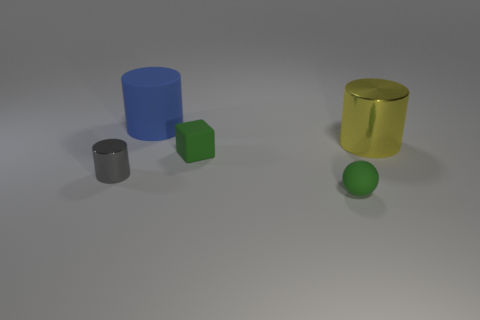There is a large cylinder in front of the big thing on the left side of the large yellow cylinder; what is it made of?
Give a very brief answer. Metal. There is a gray object that is the same shape as the big blue rubber object; what is it made of?
Offer a very short reply. Metal. Does the metallic thing right of the cube have the same size as the rubber cylinder?
Make the answer very short. Yes. What number of rubber objects are green balls or blue cylinders?
Provide a succinct answer. 2. What is the material of the cylinder that is both left of the large metal cylinder and behind the tiny cylinder?
Ensure brevity in your answer.  Rubber. Is the small gray cylinder made of the same material as the tiny green block?
Provide a short and direct response. No. There is a cylinder that is behind the gray object and in front of the large blue rubber thing; what size is it?
Your answer should be compact. Large. What is the shape of the gray metal thing?
Offer a terse response. Cylinder. What number of objects are either yellow metallic cylinders or metal objects that are right of the tiny gray shiny cylinder?
Your answer should be very brief. 1. Do the big object in front of the matte cylinder and the ball have the same color?
Offer a very short reply. No. 